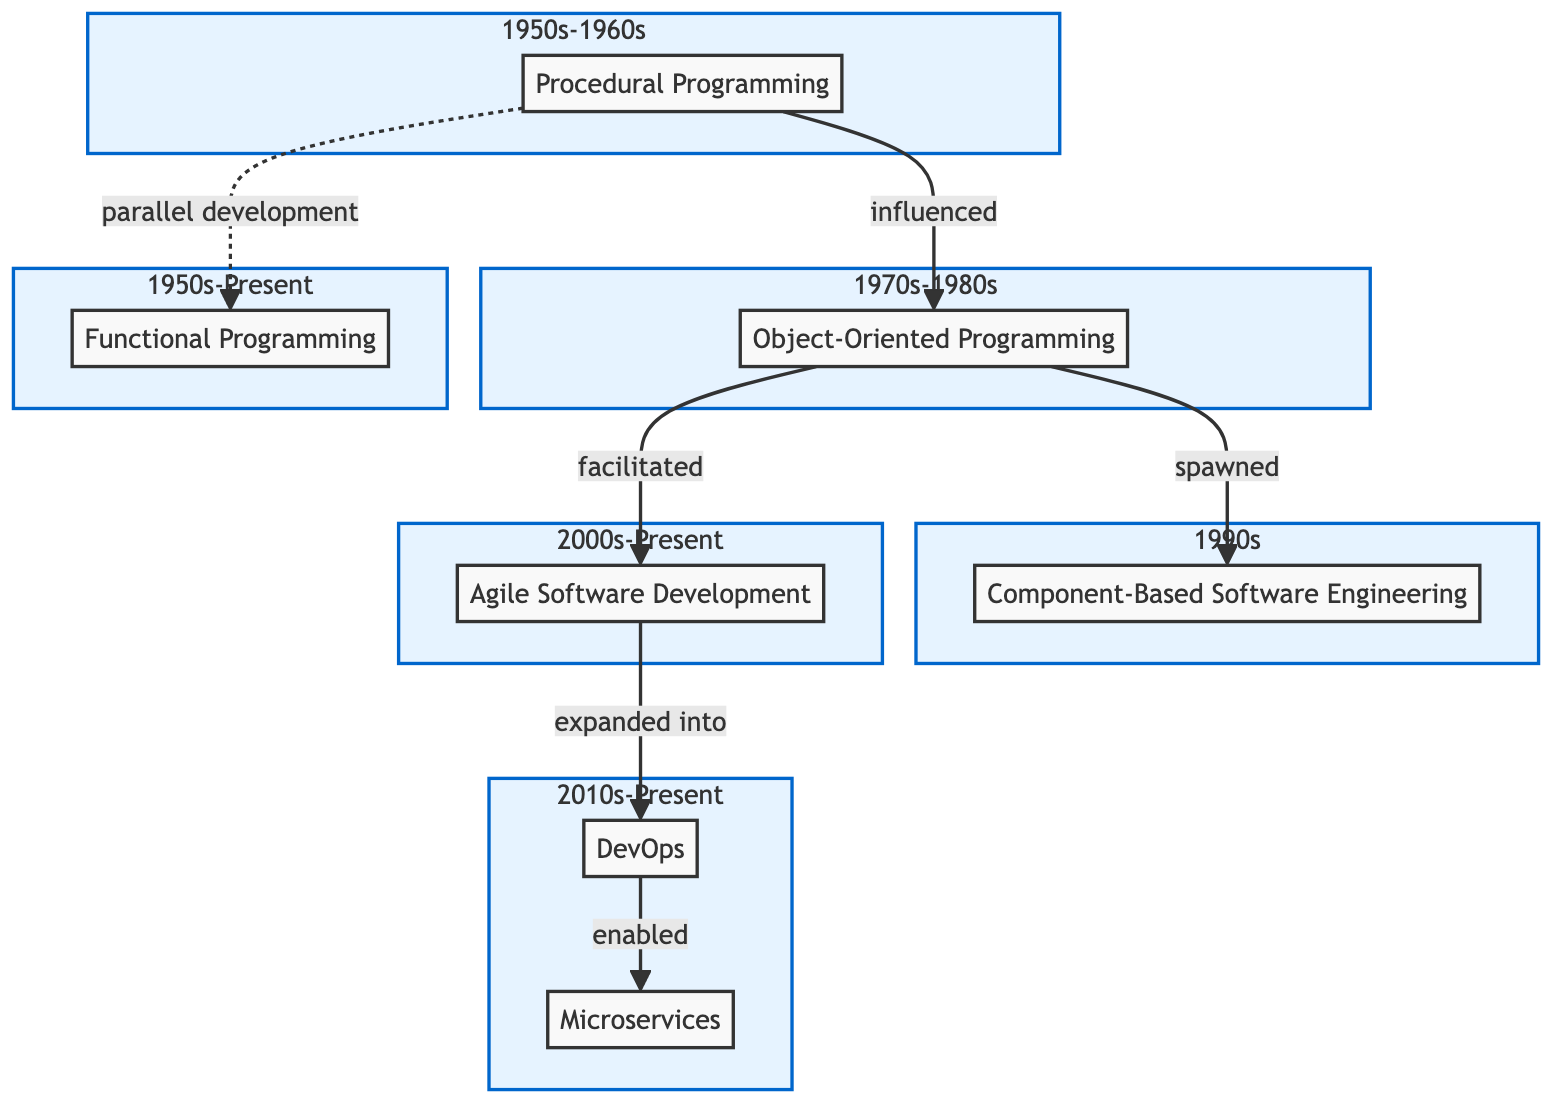What is the key language associated with Procedural Programming? According to the diagram, one of the key languages linked to Procedural Programming is Fortran. This is directly stated in the description of the Procedural Programming node.
Answer: Fortran How many paradigms are shown in the diagram? By counting the nodes within the diagram, we determine that there are a total of six distinct paradigms represented: Procedural Programming, Object-Oriented Programming, Functional Programming, Component-Based Software Engineering, Agile Software Development, and DevOps, and Microservices.
Answer: Seven What relationship exists between Object-Oriented Programming and Component-Based Software Engineering? The diagram specifies that Object-Oriented Programming has a "spawned" relationship with Component-Based Software Engineering, indicating that it gave rise to this paradigm. This is explicitly labeled on the connection line between these two nodes.
Answer: Spawned Which paradigm expanded into DevOps? The diagram clearly shows that Agile Software Development is the paradigm that expanded into DevOps. The connection labeled "expanded into" indicates that Agile Software Development played a crucial role in the formation or refinement of DevOps practices.
Answer: Agile Software Development What years encompass the evolution of Functional Programming? The diagram indicates that Functional Programming spans from the 1950s to Present. This is stated directly in the node's year field within the Functional Programming section of the diagram.
Answer: 1950s-Present How does DevOps relate to Microservices? The connection illustrated in the diagram specifies that DevOps "enabled" Microservices, which suggests that the practices and principles of DevOps support the development and deployment of Microservices architectures.
Answer: Enabled What kind of development is emphasized in Functional Programming? The description in the Functional Programming node indicates that it emphasizes pure functions and immutability, which are critical concepts in this programming paradigm. This is derived from the node’s characteristics.
Answer: Pure functions and immutability Which paradigm facilitated Agile Software Development? The diagram notes that Object-Oriented Programming facilitated Agile Software Development, indicating that advancements or concepts from Object-Oriented Programming contributed positively to the establishment of Agile methodologies.
Answer: Object-Oriented Programming What is the other term for the relationship between Procedural Programming and Functional Programming? The diagram defines the relationship as "parallel development", which means that both paradigms developed concurrently without directly influencing one another. This information is labeled on the connection line between the two nodes.
Answer: Parallel development 